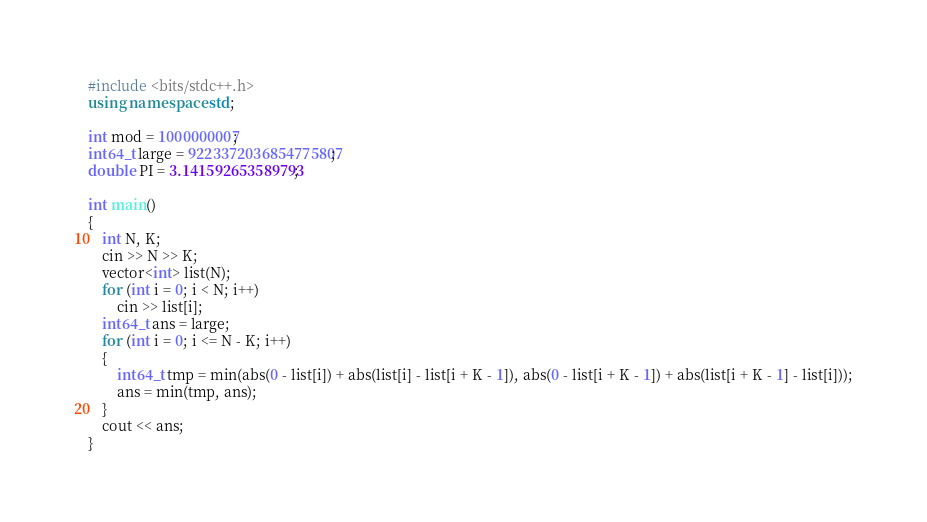<code> <loc_0><loc_0><loc_500><loc_500><_C++_>#include <bits/stdc++.h>
using namespace std;

int mod = 1000000007;
int64_t large = 9223372036854775807;
double PI = 3.141592653589793;

int main()
{
    int N, K;
    cin >> N >> K;
    vector<int> list(N);
    for (int i = 0; i < N; i++)
        cin >> list[i];
    int64_t ans = large;
    for (int i = 0; i <= N - K; i++)
    {
        int64_t tmp = min(abs(0 - list[i]) + abs(list[i] - list[i + K - 1]), abs(0 - list[i + K - 1]) + abs(list[i + K - 1] - list[i]));
        ans = min(tmp, ans);
    }
    cout << ans;
}</code> 